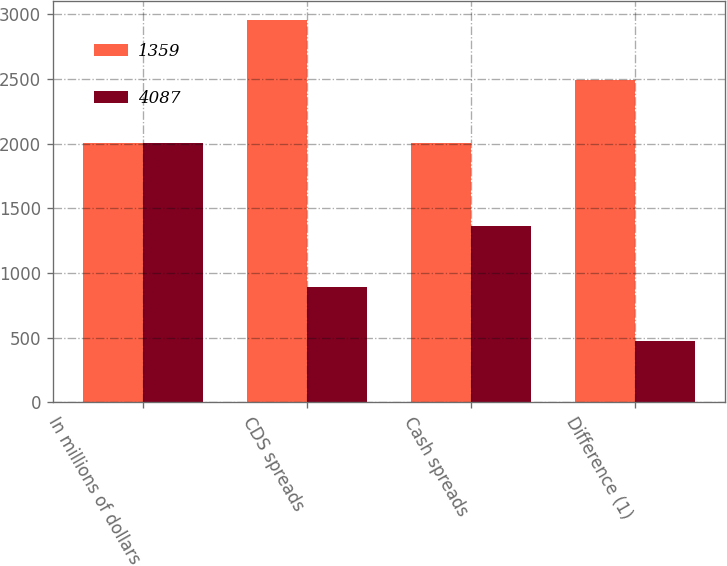Convert chart. <chart><loc_0><loc_0><loc_500><loc_500><stacked_bar_chart><ecel><fcel>In millions of dollars<fcel>CDS spreads<fcel>Cash spreads<fcel>Difference (1)<nl><fcel>1359<fcel>2008<fcel>2953<fcel>2007<fcel>2493<nl><fcel>4087<fcel>2007<fcel>888<fcel>1359<fcel>471<nl></chart> 